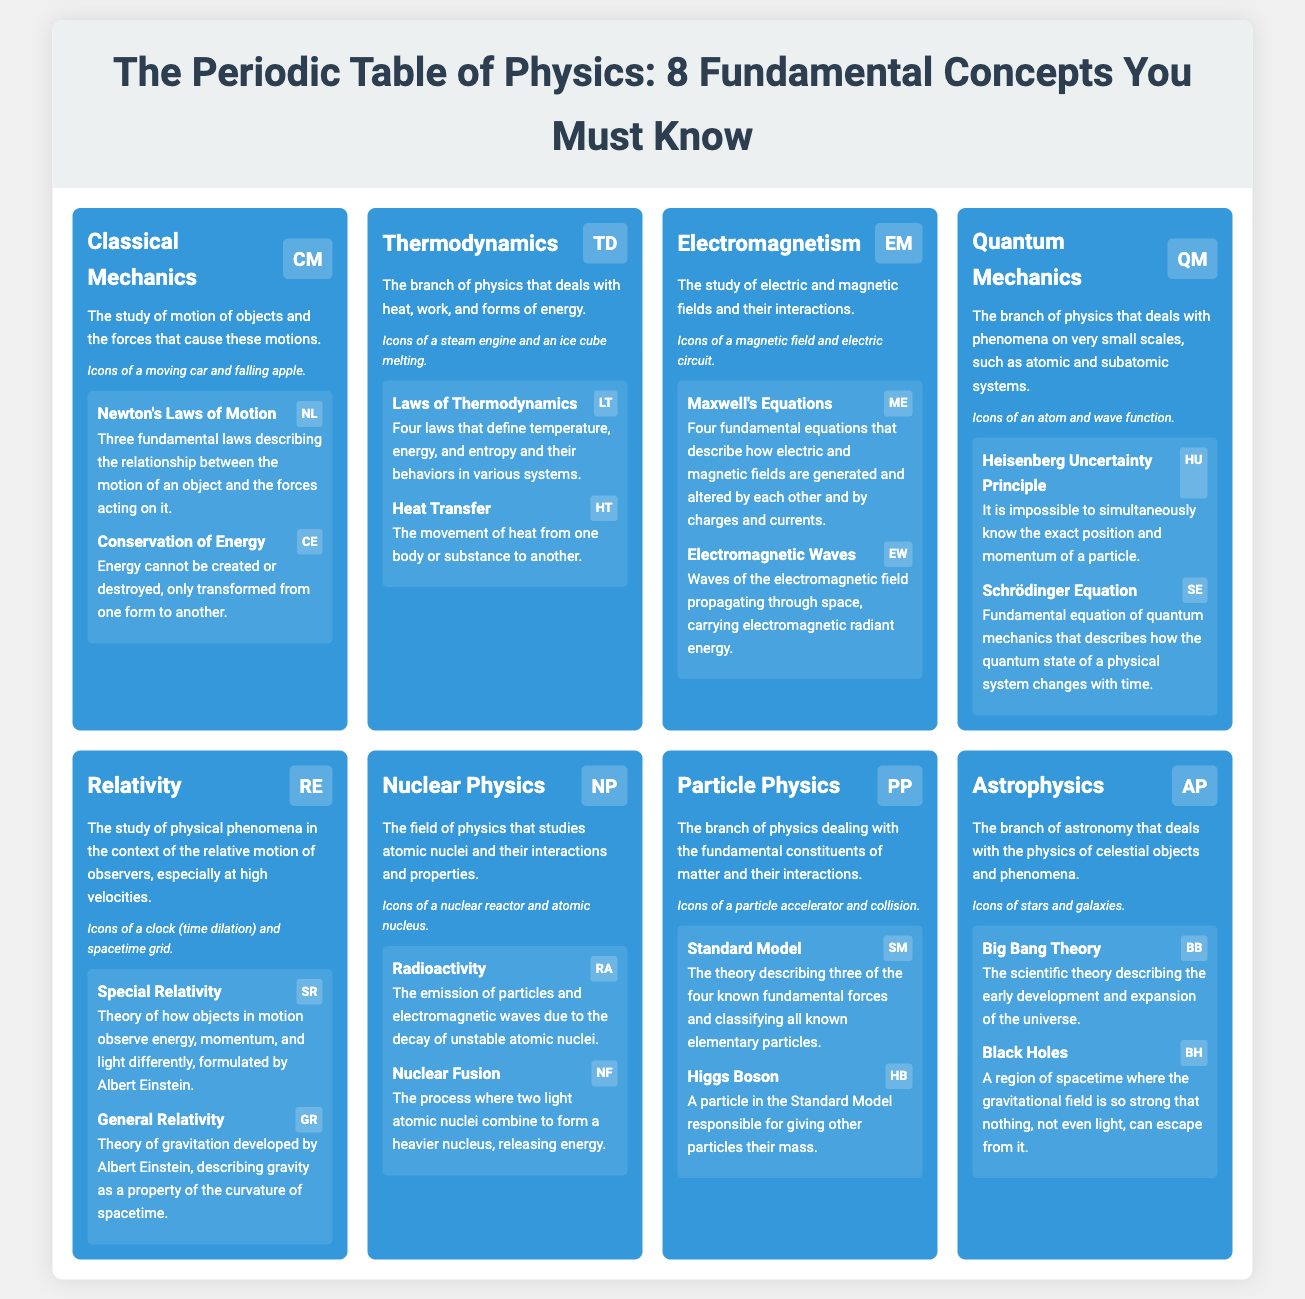What is the primary focus of Classical Mechanics? The primary focus of Classical Mechanics is the study of motion of objects and the forces that cause these motions.
Answer: Motion of objects and forces What symbol represents Quantum Mechanics? The symbol representing Quantum Mechanics in the document is QM.
Answer: QM Which concept describes "the study of electric and magnetic fields and their interactions"? This concept is named Electromagnetism.
Answer: Electromagnetism How many laws are there in Thermodynamics? There are four laws of Thermodynamics.
Answer: Four laws What is the Heisenberg Uncertainty Principle? The Heisenberg Uncertainty Principle states that it is impossible to simultaneously know the exact position and momentum of a particle.
Answer: Impossibility to know position and momentum simultaneously What does the Standard Model describe? The Standard Model describes three of the four known fundamental forces and classifies all known elementary particles.
Answer: Fundamental forces and elementary particles What is an example of a phenomenon studied in Astrophysics? An example of a phenomenon studied in Astrophysics is Black Holes.
Answer: Black Holes Which section contains "Laws of Thermodynamics"? The section that contains "Laws of Thermodynamics" is Thermodynamics.
Answer: Thermodynamics What does Nuclear Fusion refer to? Nuclear Fusion refers to the process where two light atomic nuclei combine to form a heavier nucleus, releasing energy.
Answer: Combining light atomic nuclei to form heavier nucleus 